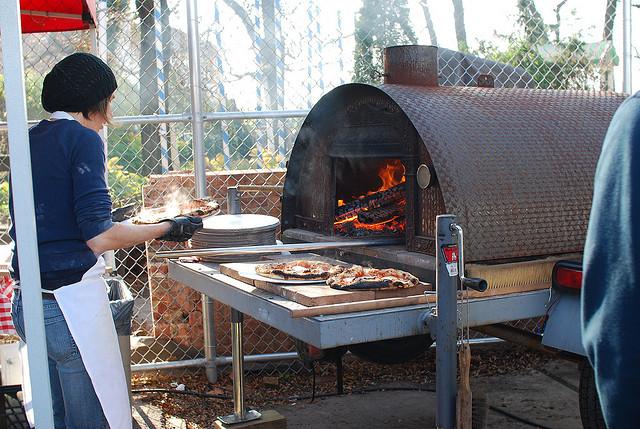What is the person cooking?
Be succinct. Pizza. What is the lady doing?
Be succinct. Cooking. What is on fire?
Give a very brief answer. Wood. 